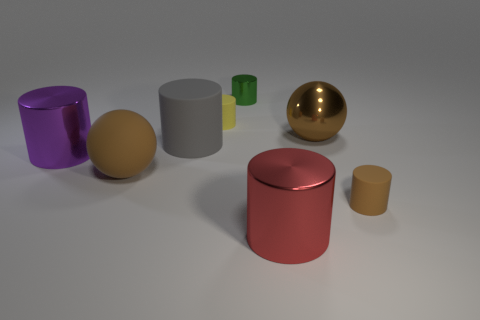Is there anything else that has the same size as the brown shiny thing?
Offer a very short reply. Yes. There is a cylinder behind the small rubber cylinder that is on the left side of the shiny ball; what is its material?
Your answer should be compact. Metal. How many rubber objects are either small blue balls or large things?
Offer a very short reply. 2. What color is the other tiny shiny thing that is the same shape as the tiny brown thing?
Your answer should be compact. Green. What number of large shiny cylinders have the same color as the tiny metal object?
Provide a succinct answer. 0. Are there any big red objects that are behind the big object that is behind the gray matte thing?
Give a very brief answer. No. What number of objects are in front of the green cylinder and to the left of the red metal thing?
Keep it short and to the point. 4. What number of other large cylinders have the same material as the red cylinder?
Offer a very short reply. 1. How big is the rubber cylinder in front of the big metal cylinder that is to the left of the rubber sphere?
Provide a short and direct response. Small. Is there a tiny brown shiny thing of the same shape as the large brown matte object?
Offer a terse response. No. 